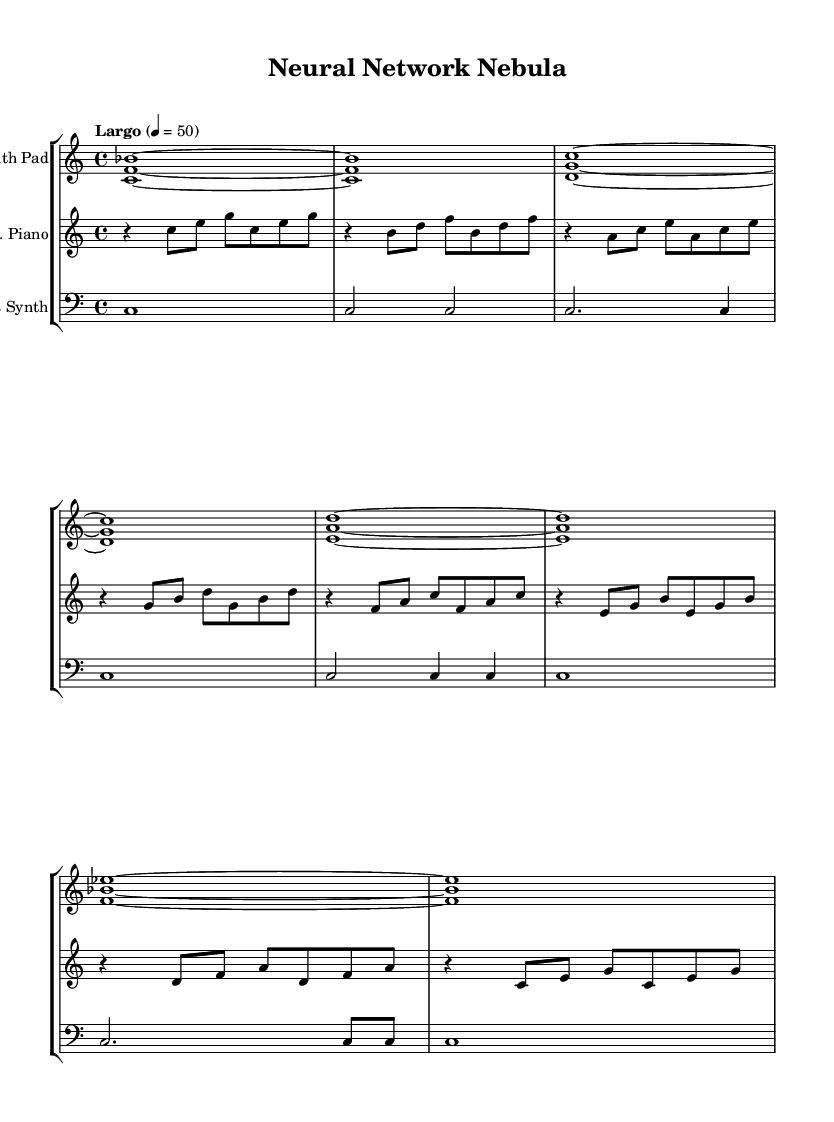What is the tempo marking for this piece? The tempo marking indicates a "Largo" pace, which is generally slow. The number provided, 4 = 50, specifies the beats per minute.
Answer: Largo What is the time signature of this music? The time signature at the beginning of the score is 4/4, meaning four beats per measure, with each quarter note receiving one beat.
Answer: 4/4 How many different instruments are used in this composition? There are three instruments listed in the score: Synth Pad, Electric Piano, and Bass Synth, each represented by a separate staff.
Answer: 3 What is the highest note in the Synth Pad part? The Synth Pad part features the note B flat, which is the highest pitch indicated throughout its measures.
Answer: B flat What is the duration of the first measure in the Electric Piano part? The first measure contains a rest followed by a sequence of eighth notes and a quarter note, amounting to the whole measure being occupied with one beat of rest and four beats of notes. The total duration sums up to one whole measure.
Answer: 4 beats What type of harmonic texture is predominantly used in this piece? The music features a harmonic texture characterized by chords played in a sustained manner, often using pad-like sounds that create an ambient feel rather than a melodic texture.
Answer: Chordal What is the specific style or genre this composition falls into? The piece is classified as "Experimental," utilizing ambient soundscapes combined with synthesizers, reflecting artistic explorations beyond traditional music forms.
Answer: Experimental 